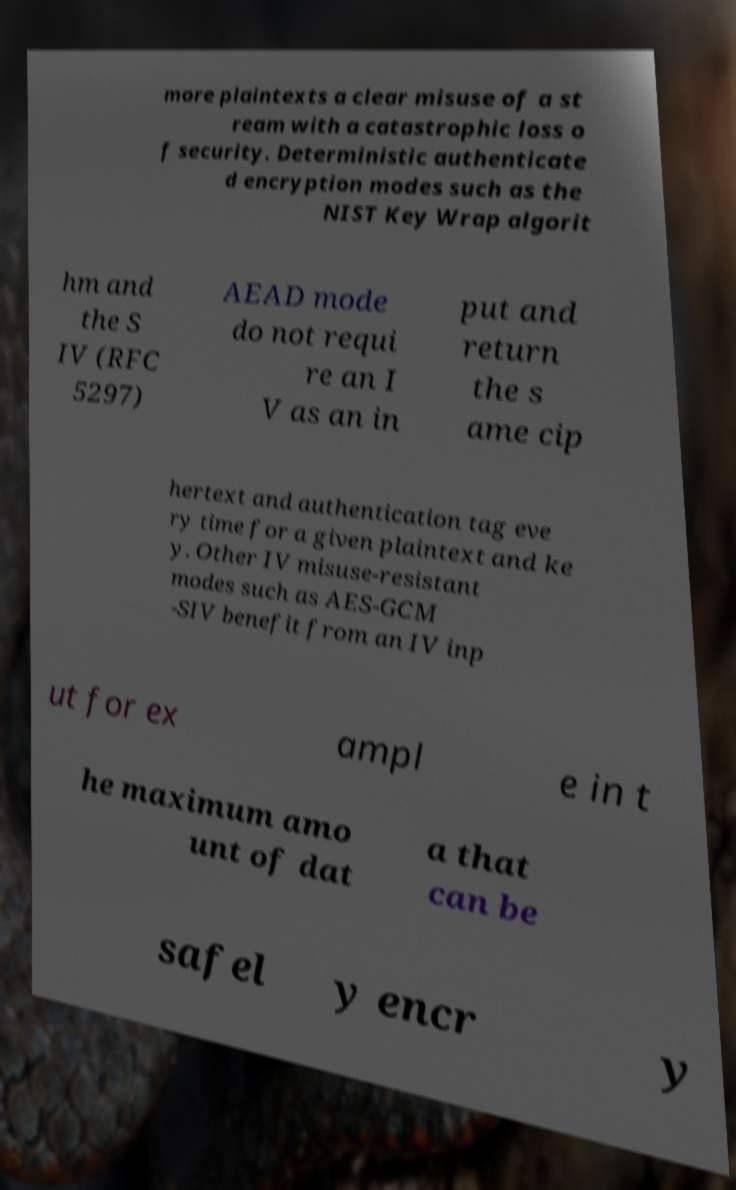Can you accurately transcribe the text from the provided image for me? more plaintexts a clear misuse of a st ream with a catastrophic loss o f security. Deterministic authenticate d encryption modes such as the NIST Key Wrap algorit hm and the S IV (RFC 5297) AEAD mode do not requi re an I V as an in put and return the s ame cip hertext and authentication tag eve ry time for a given plaintext and ke y. Other IV misuse-resistant modes such as AES-GCM -SIV benefit from an IV inp ut for ex ampl e in t he maximum amo unt of dat a that can be safel y encr y 